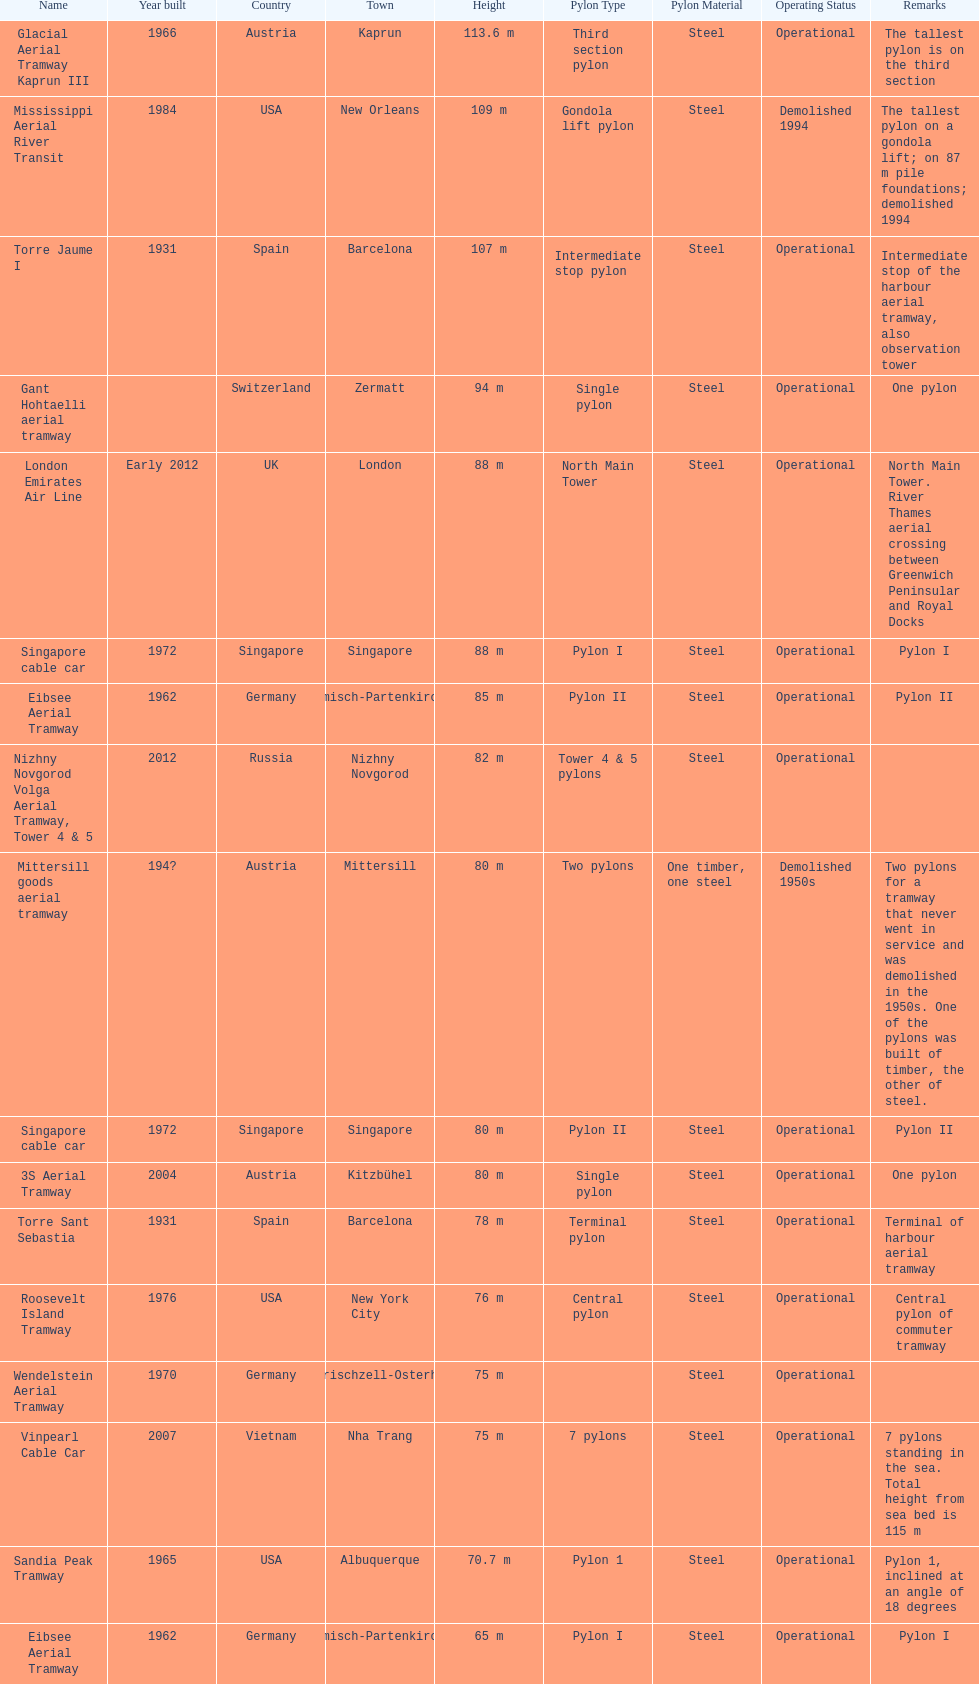List two pylons that are at most, 80 m in height. Mittersill goods aerial tramway, Singapore cable car. I'm looking to parse the entire table for insights. Could you assist me with that? {'header': ['Name', 'Year built', 'Country', 'Town', 'Height', 'Pylon Type', 'Pylon Material', 'Operating Status', 'Remarks'], 'rows': [['Glacial Aerial Tramway Kaprun III', '1966', 'Austria', 'Kaprun', '113.6 m', 'Third section pylon', 'Steel', 'Operational', 'The tallest pylon is on the third section'], ['Mississippi Aerial River Transit', '1984', 'USA', 'New Orleans', '109 m', 'Gondola lift pylon', 'Steel', 'Demolished 1994', 'The tallest pylon on a gondola lift; on 87 m pile foundations; demolished 1994'], ['Torre Jaume I', '1931', 'Spain', 'Barcelona', '107 m', 'Intermediate stop pylon', 'Steel', 'Operational', 'Intermediate stop of the harbour aerial tramway, also observation tower'], ['Gant Hohtaelli aerial tramway', '', 'Switzerland', 'Zermatt', '94 m', 'Single pylon', 'Steel', 'Operational', 'One pylon'], ['London Emirates Air Line', 'Early 2012', 'UK', 'London', '88 m', 'North Main Tower', 'Steel', 'Operational', 'North Main Tower. River Thames aerial crossing between Greenwich Peninsular and Royal Docks'], ['Singapore cable car', '1972', 'Singapore', 'Singapore', '88 m', 'Pylon I', 'Steel', 'Operational', 'Pylon I'], ['Eibsee Aerial Tramway', '1962', 'Germany', 'Garmisch-Partenkirchen', '85 m', 'Pylon II', 'Steel', 'Operational', 'Pylon II'], ['Nizhny Novgorod Volga Aerial Tramway, Tower 4 & 5', '2012', 'Russia', 'Nizhny Novgorod', '82 m', 'Tower 4 & 5 pylons', 'Steel', 'Operational', ''], ['Mittersill goods aerial tramway', '194?', 'Austria', 'Mittersill', '80 m', 'Two pylons', 'One timber, one steel', 'Demolished 1950s', 'Two pylons for a tramway that never went in service and was demolished in the 1950s. One of the pylons was built of timber, the other of steel.'], ['Singapore cable car', '1972', 'Singapore', 'Singapore', '80 m', 'Pylon II', 'Steel', 'Operational', 'Pylon II'], ['3S Aerial Tramway', '2004', 'Austria', 'Kitzbühel', '80 m', 'Single pylon', 'Steel', 'Operational', 'One pylon'], ['Torre Sant Sebastia', '1931', 'Spain', 'Barcelona', '78 m', 'Terminal pylon', 'Steel', 'Operational', 'Terminal of harbour aerial tramway'], ['Roosevelt Island Tramway', '1976', 'USA', 'New York City', '76 m', 'Central pylon', 'Steel', 'Operational', 'Central pylon of commuter tramway'], ['Wendelstein Aerial Tramway', '1970', 'Germany', 'Bayerischzell-Osterhofen', '75 m', '', 'Steel', 'Operational', ''], ['Vinpearl Cable Car', '2007', 'Vietnam', 'Nha Trang', '75 m', '7 pylons', 'Steel', 'Operational', '7 pylons standing in the sea. Total height from sea bed is 115 m'], ['Sandia Peak Tramway', '1965', 'USA', 'Albuquerque', '70.7 m', 'Pylon 1', 'Steel', 'Operational', 'Pylon 1, inclined at an angle of 18 degrees'], ['Eibsee Aerial Tramway', '1962', 'Germany', 'Garmisch-Partenkirchen', '65 m', 'Pylon I', 'Steel', 'Operational', 'Pylon I']]} 